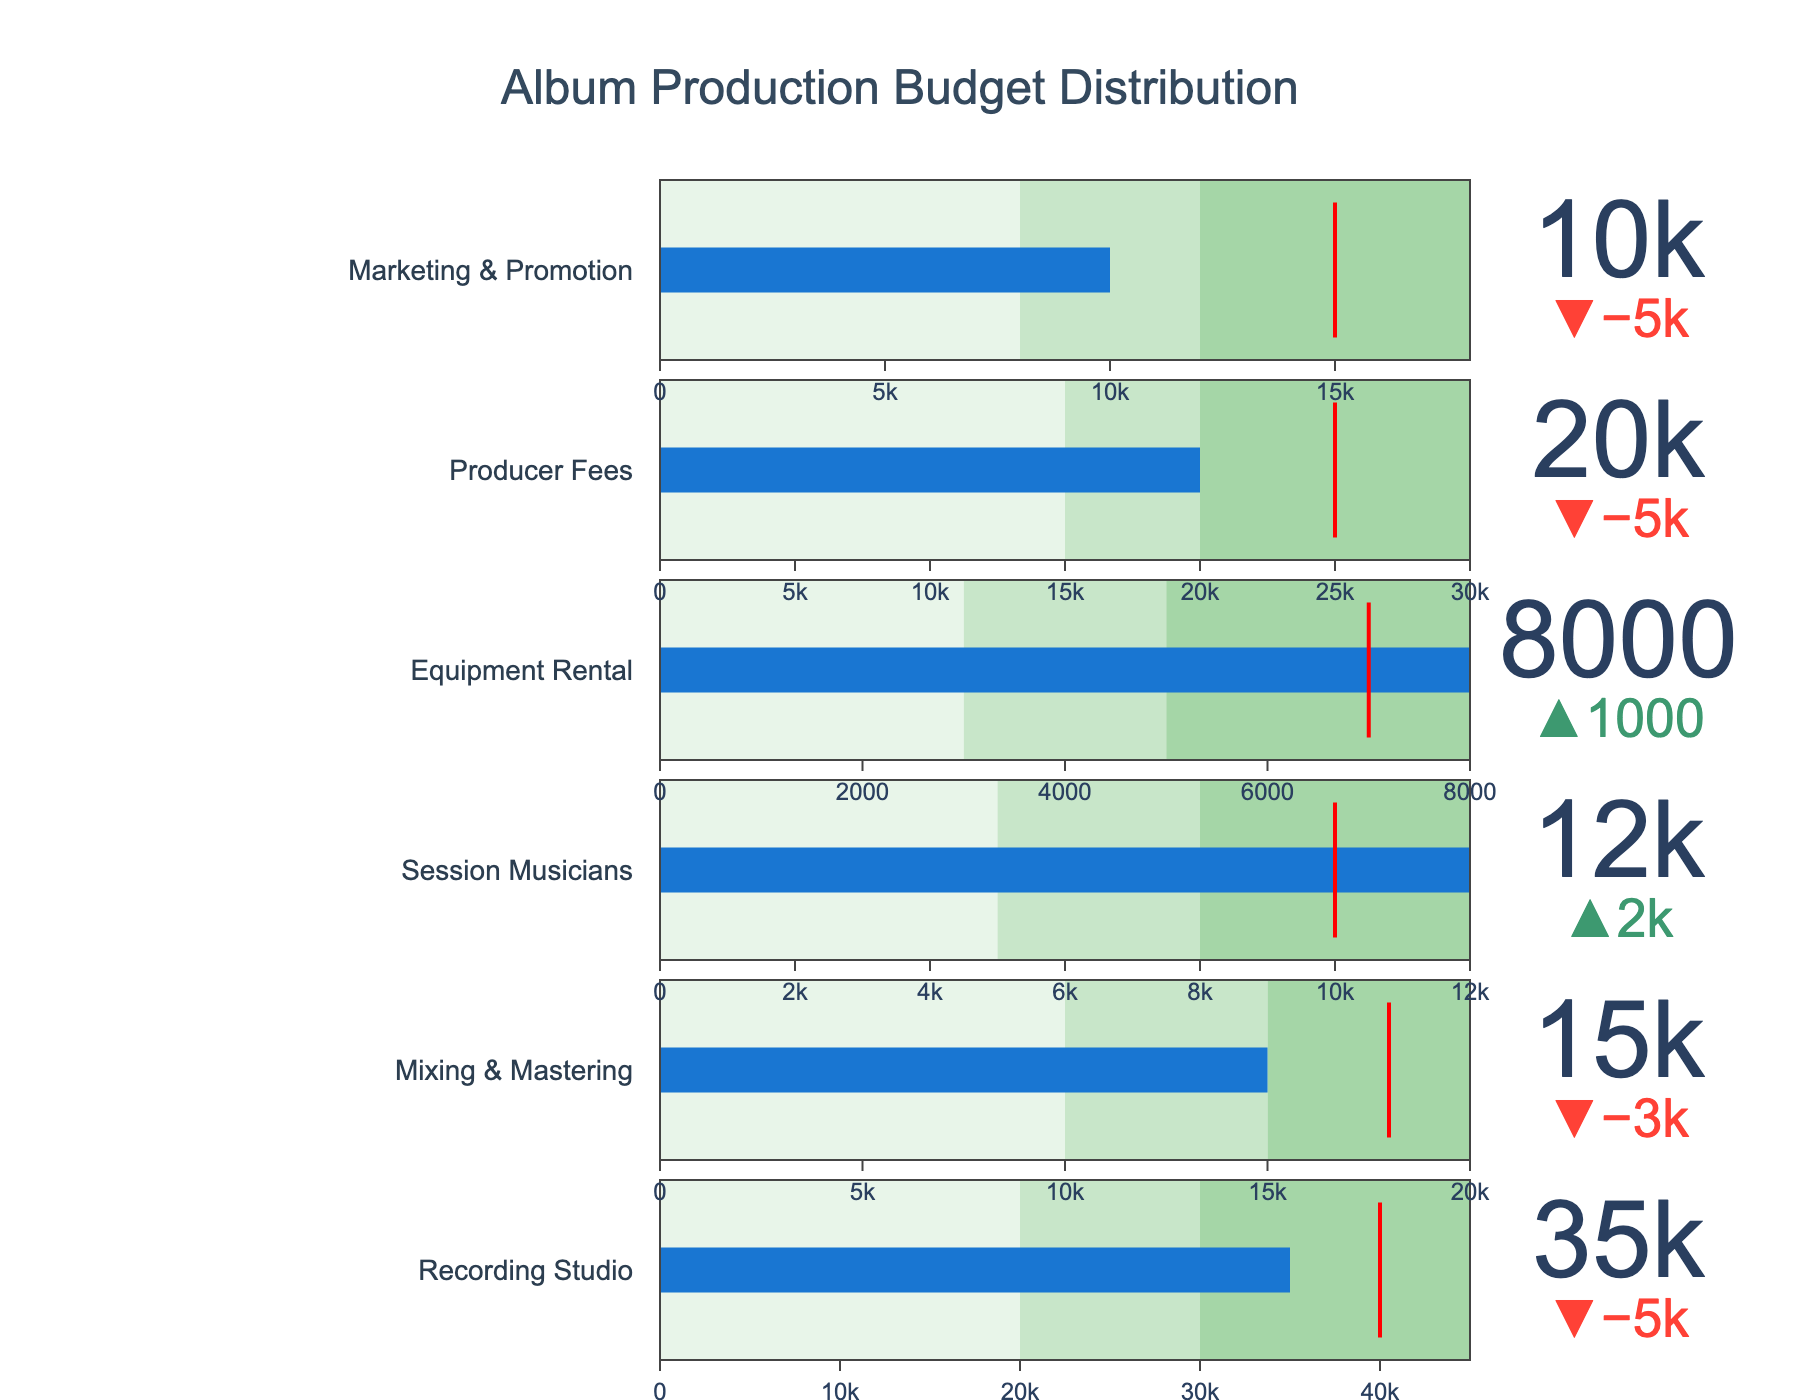what is the title of the chart? The title is written at the top of the chart, centered within the plot area, and it provides a description of the data visualized in the chart.
Answer: Album Production Budget Distribution what is the actual expense for recording studio? Look for the category "Recording Studio" and identify the actual expense value indicated by the colored bar.
Answer: 35000 which category has the smallest budget target? Compare the target values for each category and identify the one with the smallest value.
Answer: Equipment Rental how much more was spent on session musicians than the budget target? Subtract the target value for "Session Musicians" from the actual expense value to find the difference. \( 12000 - 10000 = 2000 \)
Answer: 2000 how does the actual marketing and promotion expense compare to its target? Identify the actual expense and target value for "Marketing & Promotion" and determine if the actual expense is less than, greater than, or equal to the target value.
Answer: Less than what is the target value for producer fees? Look for the category "Producer Fees" and identify the target value indicated by the threshold line.
Answer: 25000 which category exceeded its range3 threshold? Identify the bar (actual expense) that is longer than the entire range3 for each category. None of the bars exceed the highest threshold within their ranges.
Answer: None is the actual expense for mixing & mastering within its optimal range? Determine the optimal range (Range2) for "Mixing & Mastering" and see if the actual expense falls within this range.
Answer: Yes which category has the actual expense closest to its target? Calculate the absolute difference between the actual and target values for each category and identify the smallest one.
Answer: Session Musicians which category has the widest range3? Compare the range3 values for all categories and identify the one with the largest value.
Answer: Recording Studio 